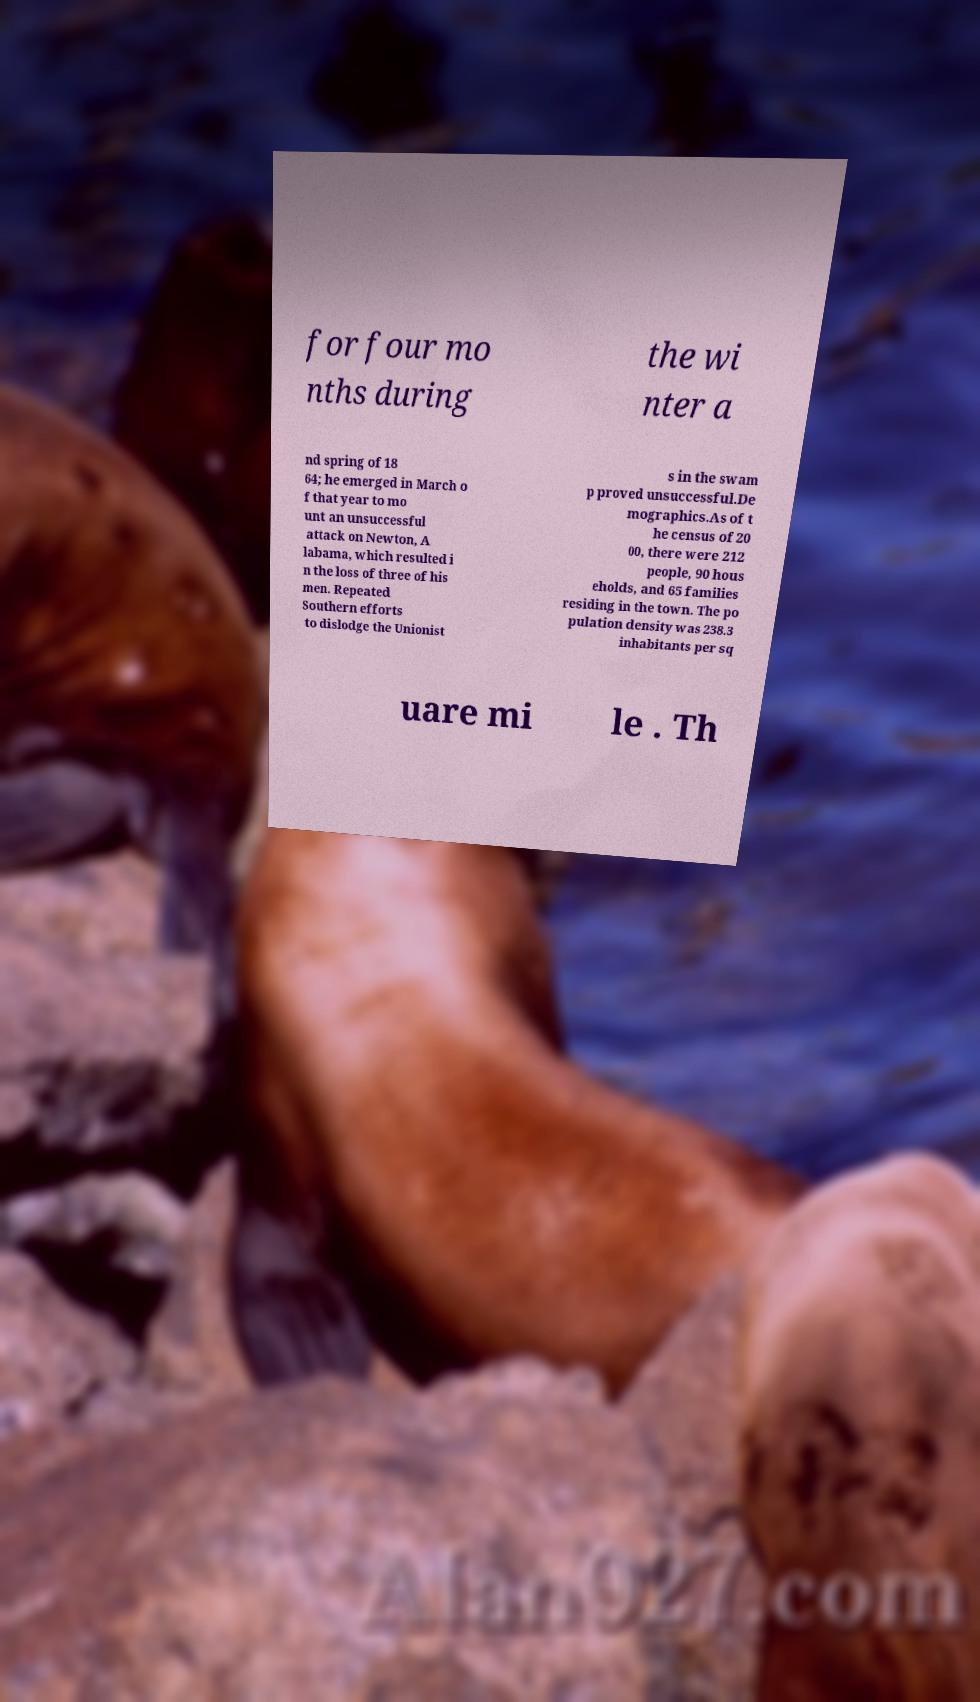Can you read and provide the text displayed in the image?This photo seems to have some interesting text. Can you extract and type it out for me? for four mo nths during the wi nter a nd spring of 18 64; he emerged in March o f that year to mo unt an unsuccessful attack on Newton, A labama, which resulted i n the loss of three of his men. Repeated Southern efforts to dislodge the Unionist s in the swam p proved unsuccessful.De mographics.As of t he census of 20 00, there were 212 people, 90 hous eholds, and 65 families residing in the town. The po pulation density was 238.3 inhabitants per sq uare mi le . Th 